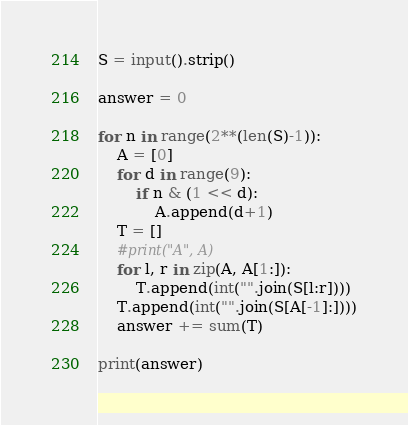Convert code to text. <code><loc_0><loc_0><loc_500><loc_500><_Python_>S = input().strip()

answer = 0

for n in range(2**(len(S)-1)):
    A = [0]
    for d in range(9):
        if n & (1 << d):
            A.append(d+1)
    T = []
    #print("A", A)
    for l, r in zip(A, A[1:]):
        T.append(int("".join(S[l:r])))
    T.append(int("".join(S[A[-1]:])))
    answer += sum(T)

print(answer)
</code> 